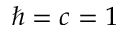<formula> <loc_0><loc_0><loc_500><loc_500>\hbar { = } c = 1</formula> 